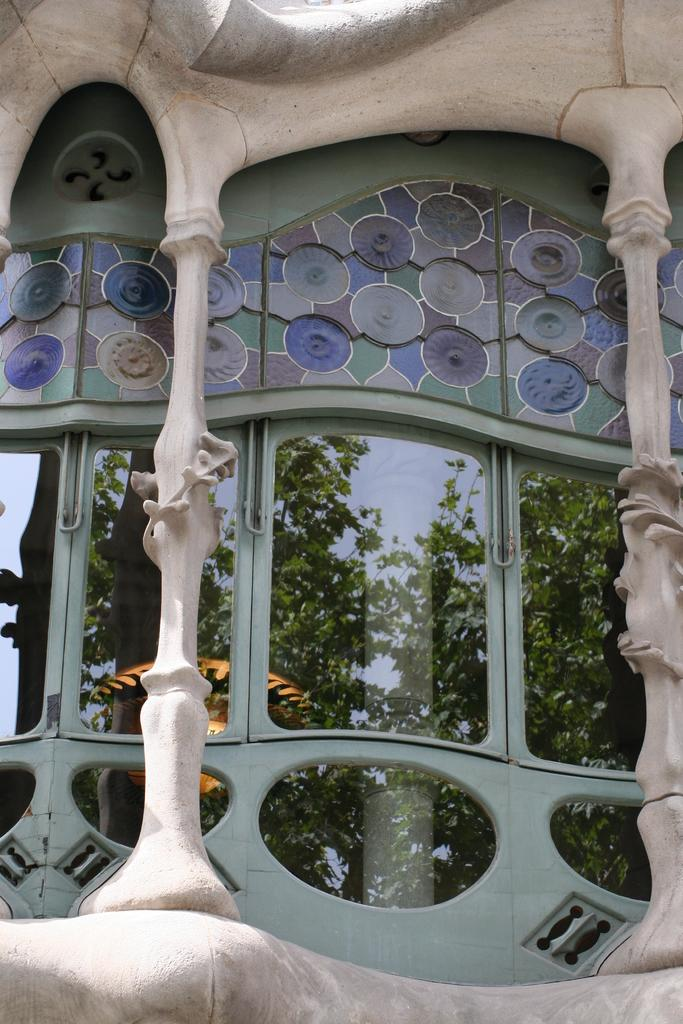What type of natural elements can be seen reflected in the image? There are reflections of trees and the sky in the image. What type of structure is depicted in the image? The image appears to depict a building. Where is the cannon located in the image? There is no cannon present in the image. What type of animal is standing next to the building in the image? There is no animal, such as a donkey, present in the image. What type of plant can be seen growing out of the building in the image? There is no plant, such as a root, growing out of the building in the image. 